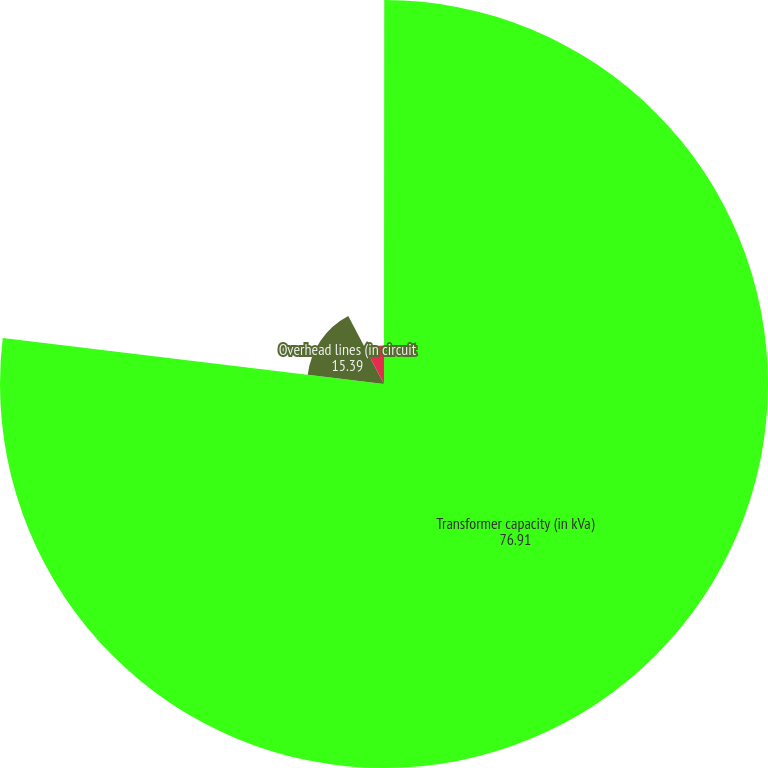Convert chart. <chart><loc_0><loc_0><loc_500><loc_500><pie_chart><fcel>Number of substations owned<fcel>Transformer capacity (in kVa)<fcel>Overhead lines (in circuit<fcel>Underground lines<nl><fcel>0.01%<fcel>76.91%<fcel>15.39%<fcel>7.7%<nl></chart> 